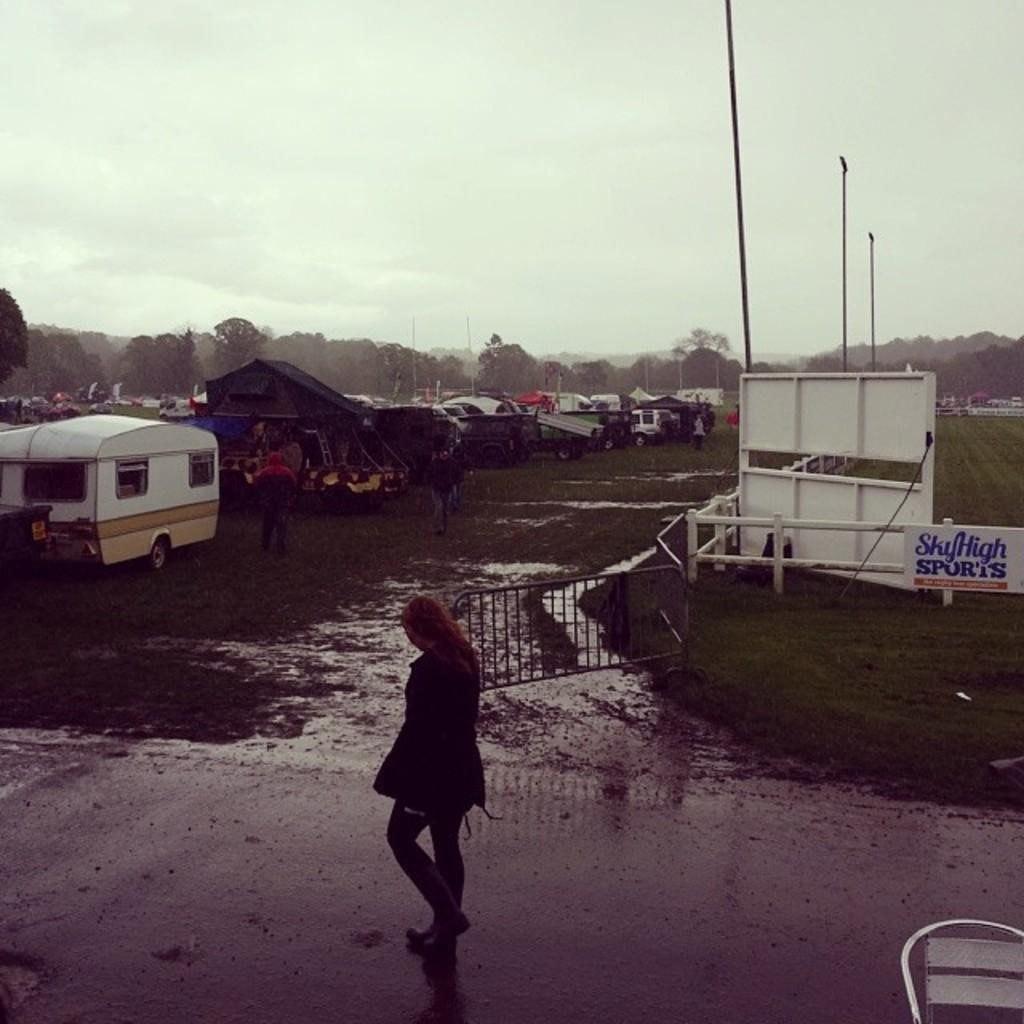In one or two sentences, can you explain what this image depicts? In this image on the left side there are some vehicles, tents and some persons are walking. In the foreground there is one woman who is walking, on the right side there is a railing and board and some poles. In the background there are some mountains, trees, and poles. At the top of the image there is sky and at the bottom three is road and grass. 